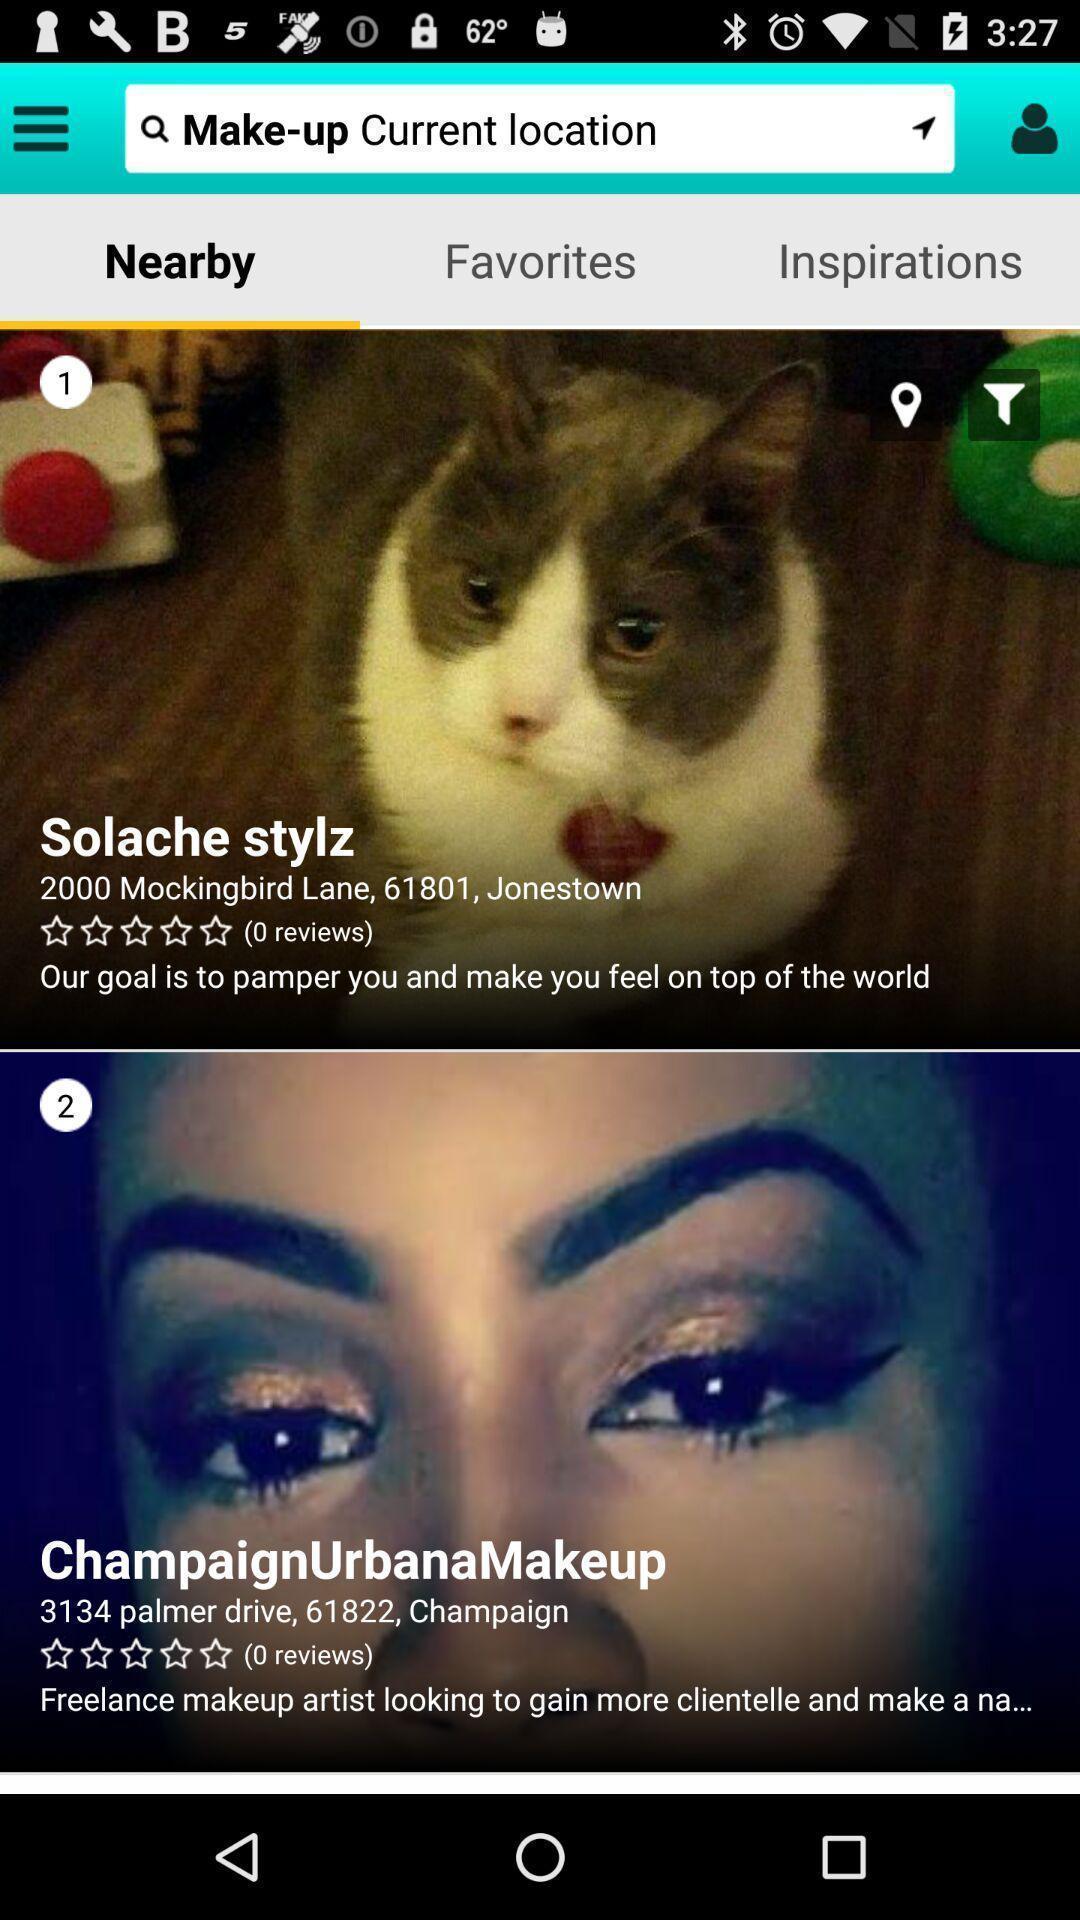Provide a textual representation of this image. Page showing variety of profiles. 